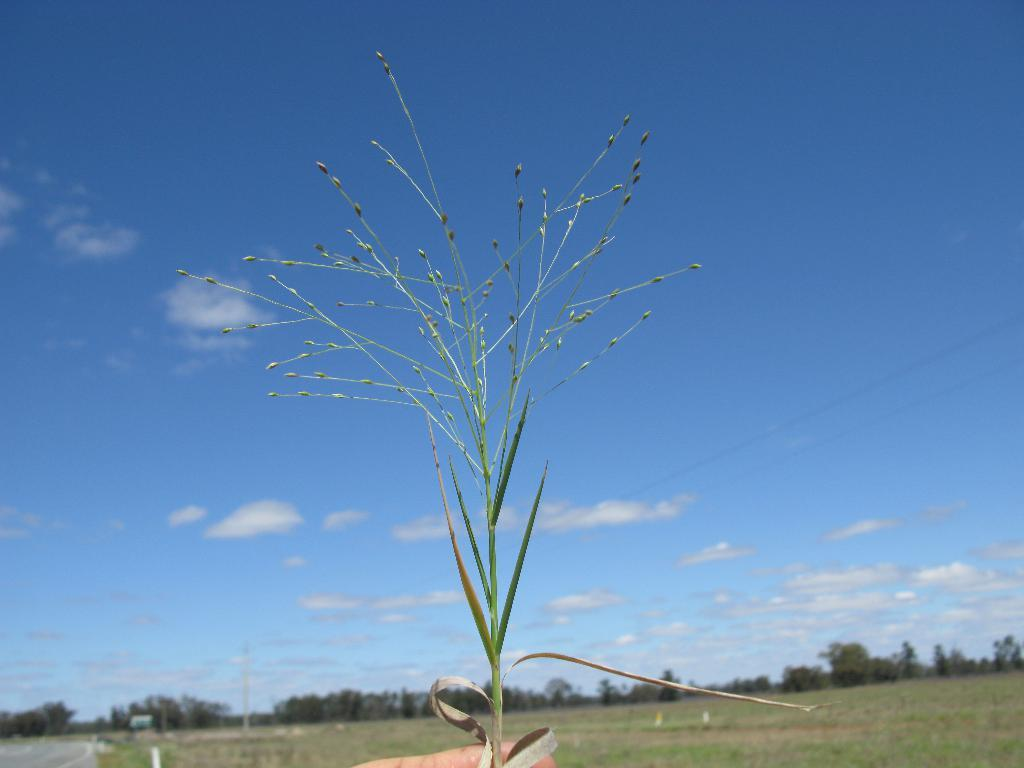What can be seen in the sky in the image? The sky with clouds is visible in the image. What type of vegetation is present in the image? There are trees in the image. What is the surface visible in the image? The ground is visible in the image. Is there any plant life in the image? Yes, there is a plant in the image. Can you tell me how many monkeys are climbing the trees in the image? There are no monkeys present in the image; it features trees, clouds, and a plant. What type of coil is used to support the plant in the image? There is no coil visible in the image; the plant is standing on the ground. 